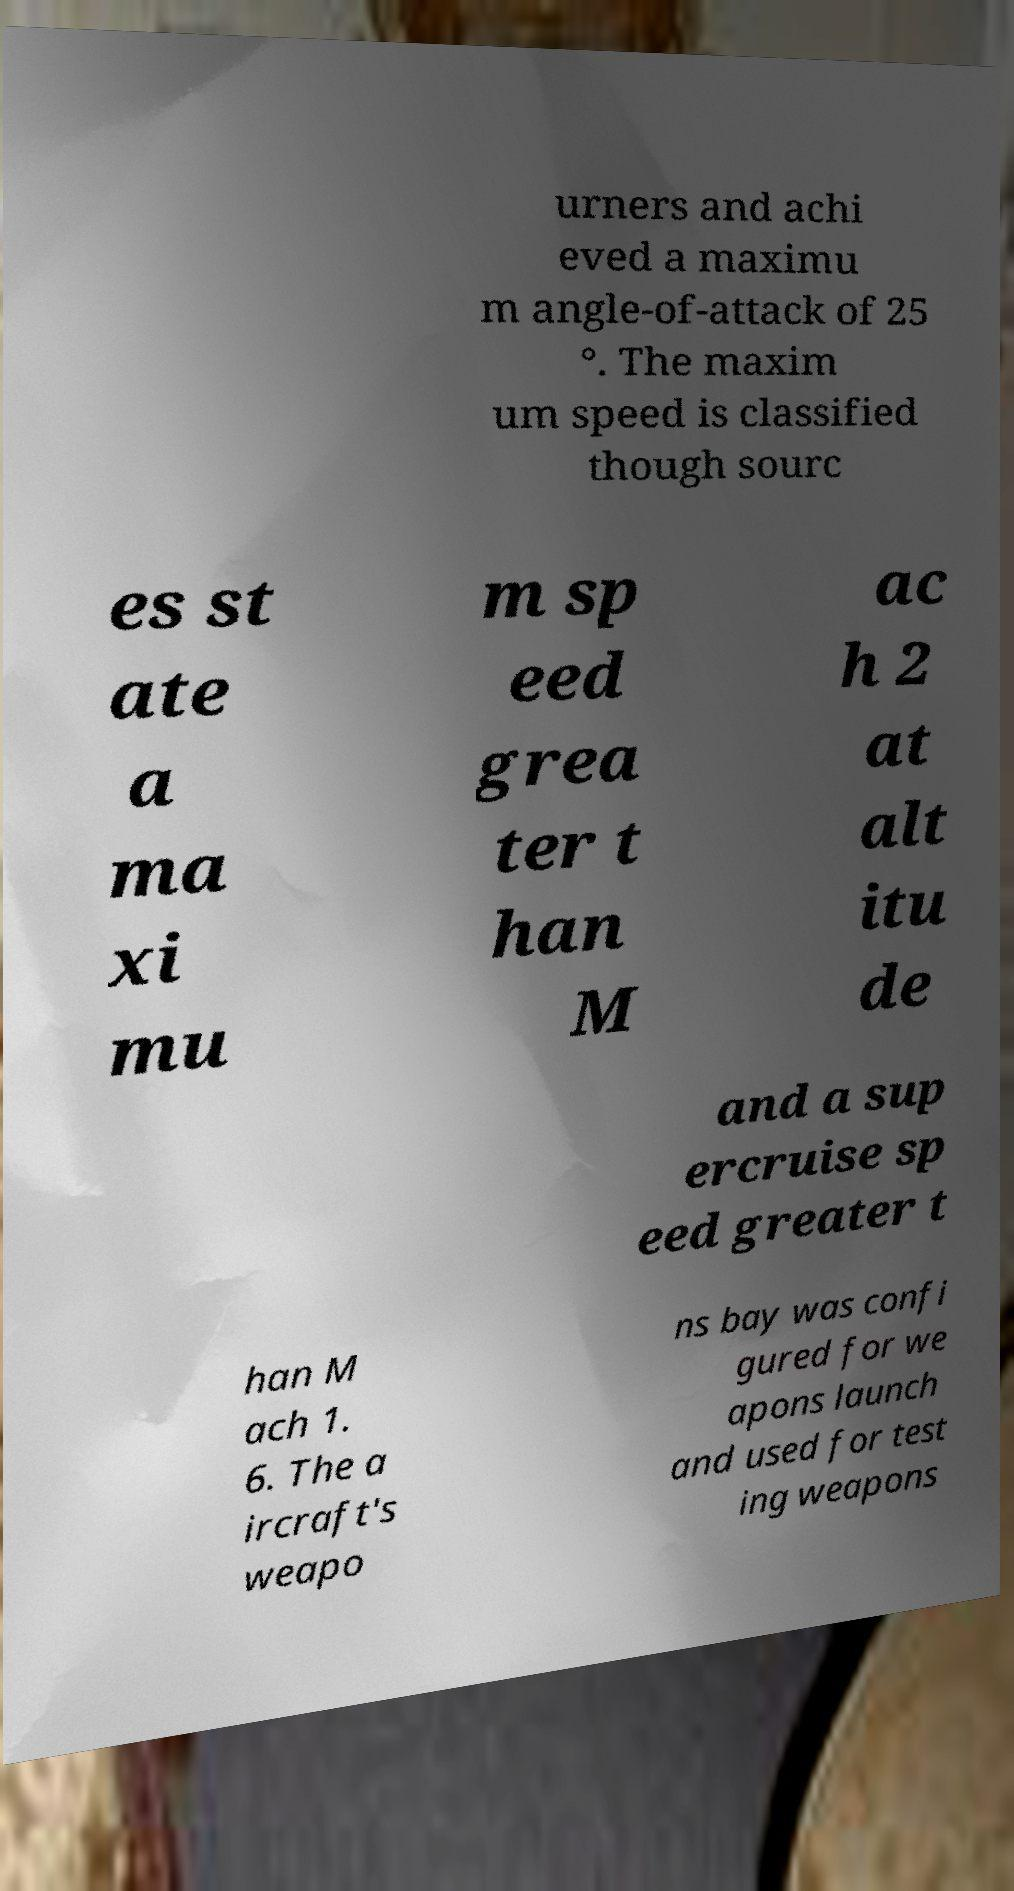What messages or text are displayed in this image? I need them in a readable, typed format. urners and achi eved a maximu m angle-of-attack of 25 °. The maxim um speed is classified though sourc es st ate a ma xi mu m sp eed grea ter t han M ac h 2 at alt itu de and a sup ercruise sp eed greater t han M ach 1. 6. The a ircraft's weapo ns bay was confi gured for we apons launch and used for test ing weapons 